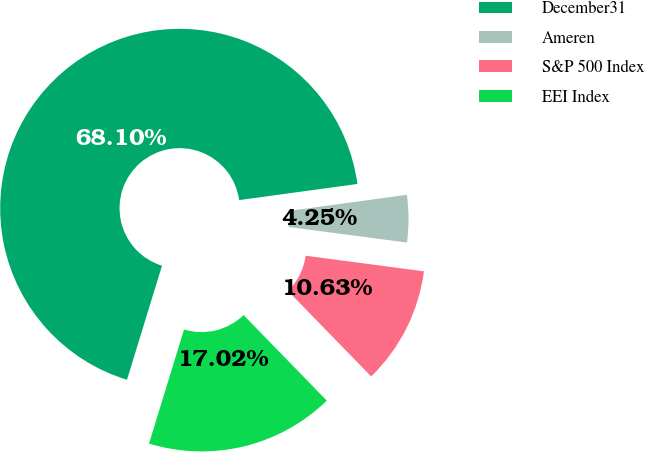Convert chart. <chart><loc_0><loc_0><loc_500><loc_500><pie_chart><fcel>December31<fcel>Ameren<fcel>S&P 500 Index<fcel>EEI Index<nl><fcel>68.1%<fcel>4.25%<fcel>10.63%<fcel>17.02%<nl></chart> 